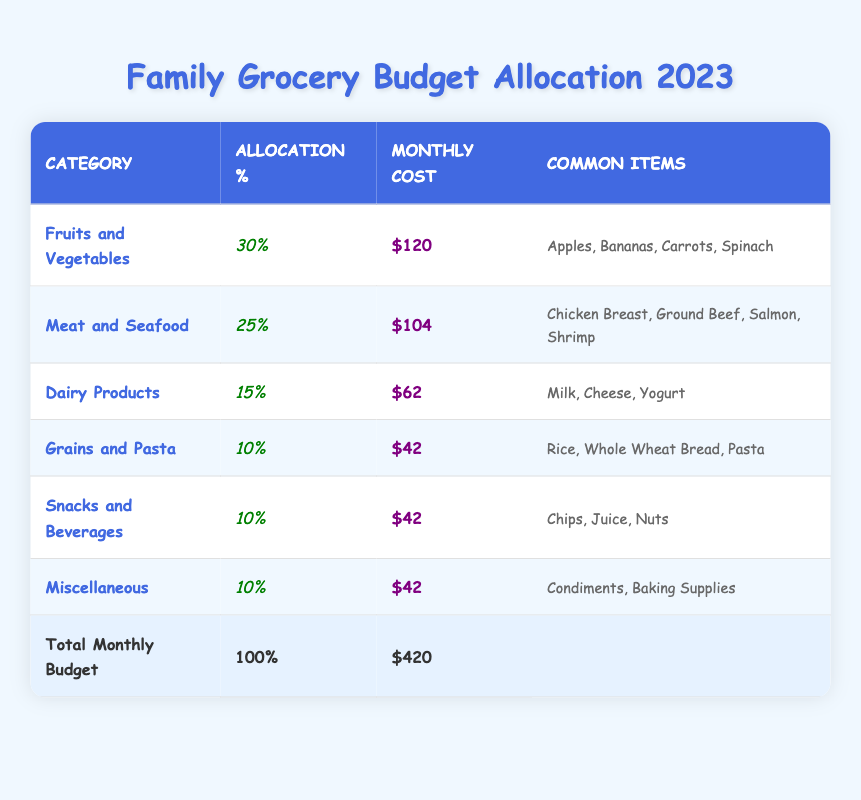What percentage of the budget is allocated to Dairy Products? The table shows that Dairy Products have an allocation percentage of 15%. Therefore, the percentage is directly stated in the table.
Answer: 15% What is the average monthly cost for the Snacks and Beverages category? The average monthly cost for Snacks and Beverages is directly provided in the table as $42.
Answer: $42 How much more is allocated to Fruits and Vegetables compared to Grains and Pasta? The allocation percentage for Fruits and Vegetables is 30%, while Grains and Pasta is 10%. The difference is 30% - 10% = 20%.
Answer: 20% Is the total monthly budget greater than $400? The total monthly budget listed in the table is $420, which is indeed greater than $400. Therefore, the statement is true.
Answer: Yes If we combine the average monthly costs of Fruits and Vegetables, Meat and Seafood, and Dairy Products, what is the total? The average monthly costs for these categories are $120 (Fruits and Vegetables), $104 (Meat and Seafood), and $62 (Dairy Products). Summing these amounts gives us $120 + $104 + $62 = $286.
Answer: $286 Which category has the highest allocation percentage and what is that percentage? By reviewing the allocation percentages, Fruits and Vegetables have the highest allocation at 30%. This can be found by comparing all categories in the table.
Answer: 30% What percentage of the total monthly budget is spent on Meat and Seafood? The table states that Meat and Seafood has an allocation percentage of 25%. This percentage is straightforwardly listed.
Answer: 25% What is the total monthly cost for all categories except for Snacks and Beverages? The average monthly costs for the other categories are $120 (Fruits and Vegetables) + $104 (Meat and Seafood) + $62 (Dairy Products) + $42 (Grains and Pasta) + $42 (Miscellaneous). Summing these values gives $120 + $104 + $62 + $42 + $42 = $370.
Answer: $370 Do Snacks and Beverages have a higher allocation percentage than Grains and Pasta? The allocation percentage for Snacks and Beverages is 10%, which is equal to the allocation percentage for Grains and Pasta. Therefore, the answer is no.
Answer: No 